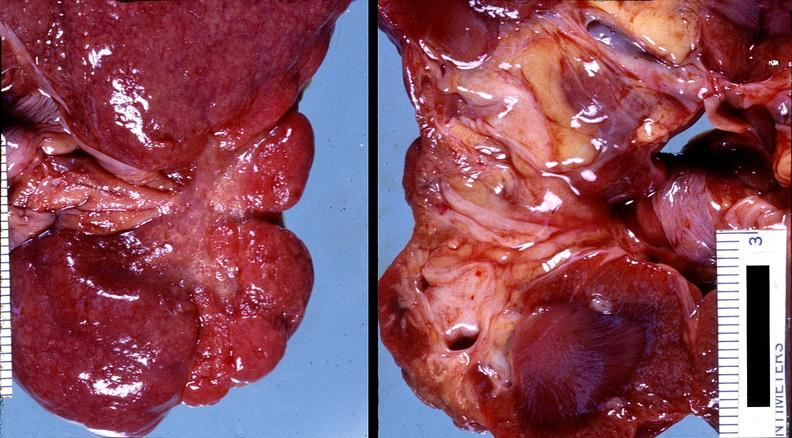does retroperitoneal liposarcoma show kidney, pyelonephritis?
Answer the question using a single word or phrase. No 